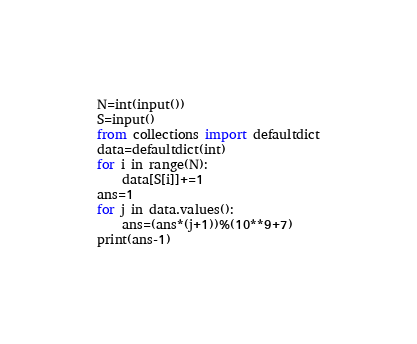Convert code to text. <code><loc_0><loc_0><loc_500><loc_500><_Python_>N=int(input())
S=input()
from collections import defaultdict
data=defaultdict(int)
for i in range(N):
    data[S[i]]+=1
ans=1
for j in data.values():
    ans=(ans*(j+1))%(10**9+7)
print(ans-1)</code> 